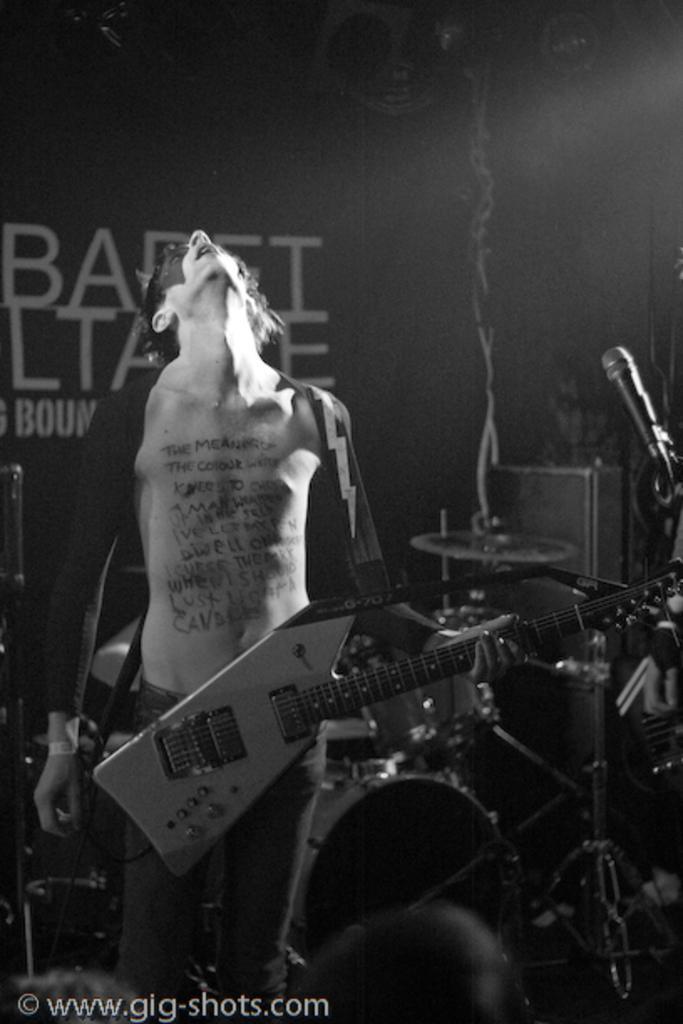Can you describe this image briefly? A man is holding guitar in his hand behind him there are musical instruments and a banner. 